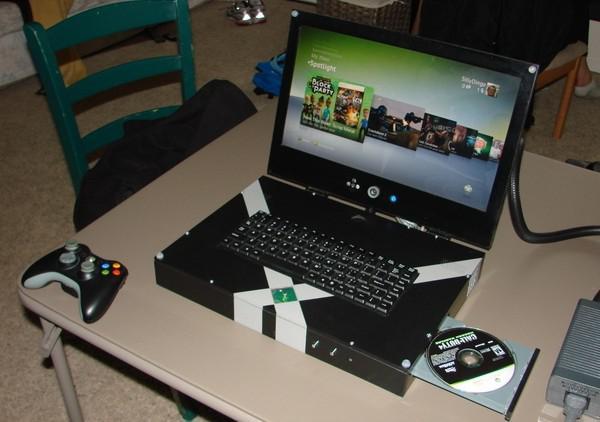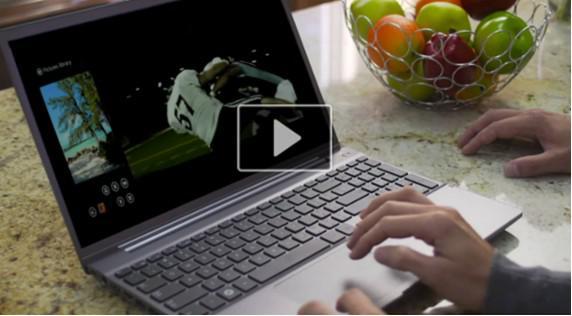The first image is the image on the left, the second image is the image on the right. For the images displayed, is the sentence "Human hands are near a keyboard in one image." factually correct? Answer yes or no. Yes. The first image is the image on the left, the second image is the image on the right. Given the left and right images, does the statement "There is at least one human hand that is at least partially visible" hold true? Answer yes or no. Yes. 